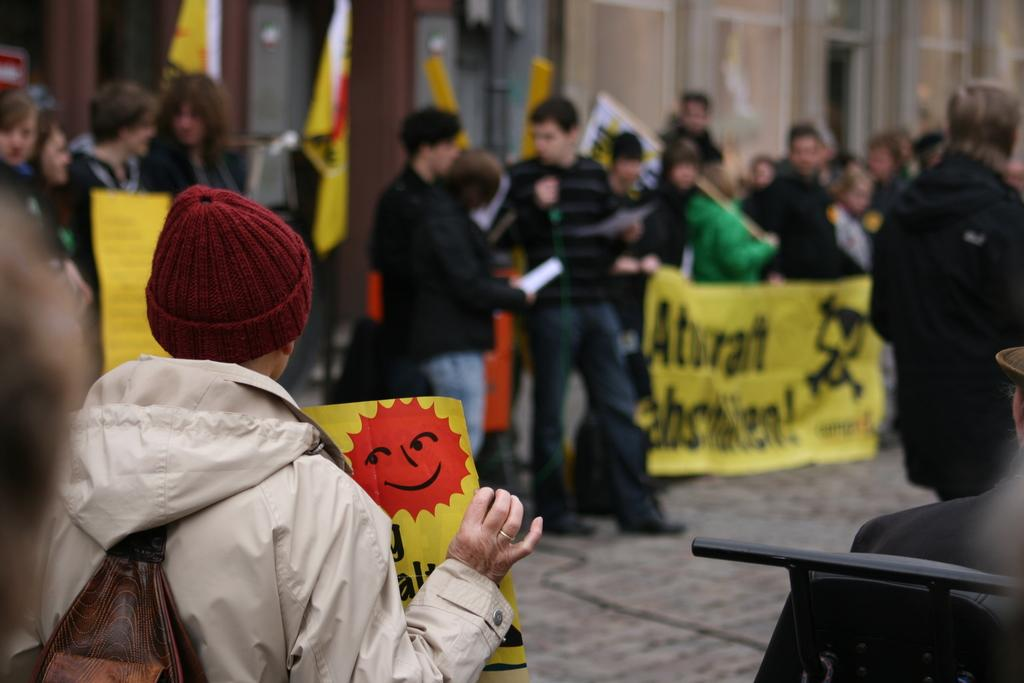How many people are in the image? There is a group of people in the image, but the exact number cannot be determined from the provided facts. What are the people holding in the image? The people are holding banners and posters in the image. What else can be seen in the image besides the people? There are flags in the image. What is visible in the background of the image? There is a building in the background of the image, and the background is blurry. What type of advice can be seen written on the cork in the image? There is no cork present in the image, and therefore no advice can be seen written on it. 